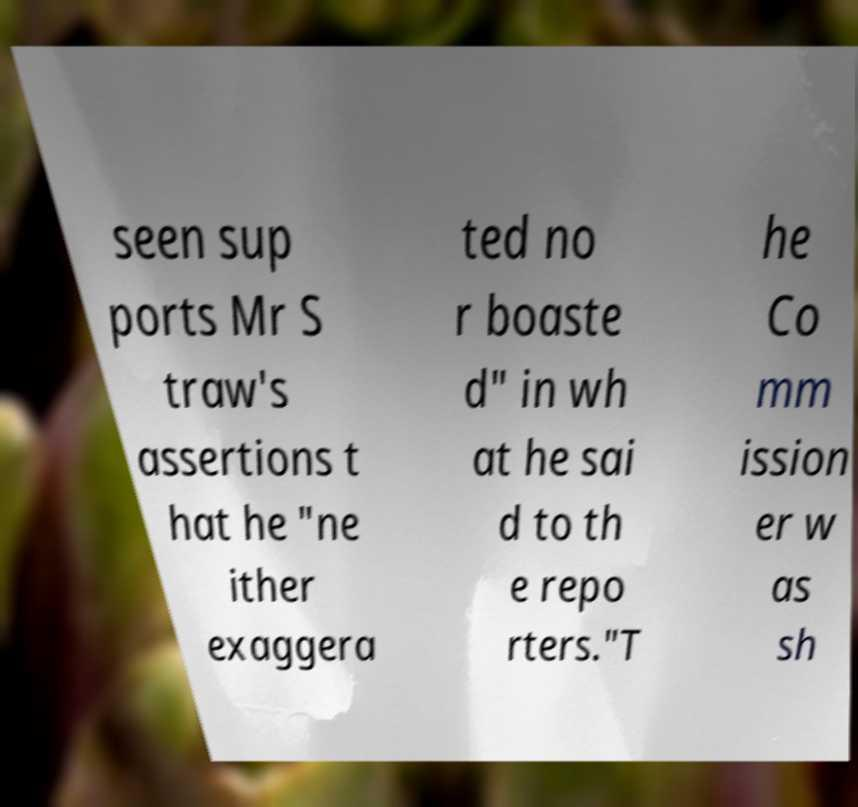For documentation purposes, I need the text within this image transcribed. Could you provide that? seen sup ports Mr S traw's assertions t hat he "ne ither exaggera ted no r boaste d" in wh at he sai d to th e repo rters."T he Co mm ission er w as sh 